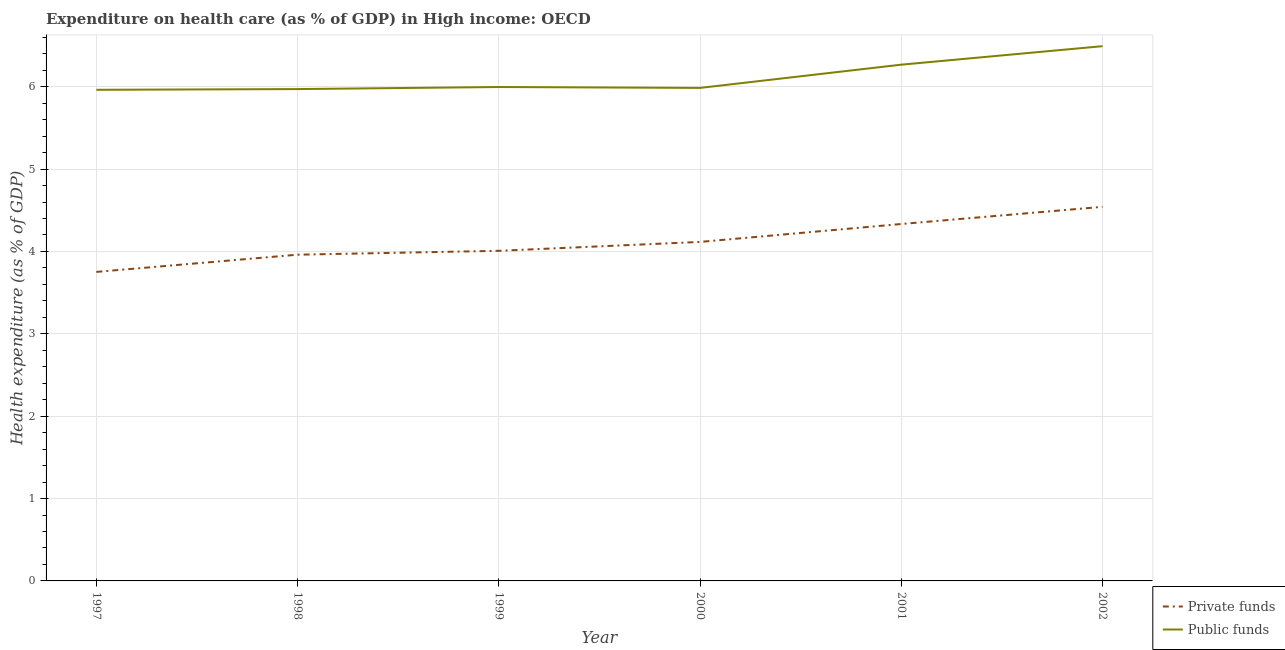What is the amount of public funds spent in healthcare in 1998?
Your response must be concise. 5.97. Across all years, what is the maximum amount of public funds spent in healthcare?
Provide a short and direct response. 6.49. Across all years, what is the minimum amount of public funds spent in healthcare?
Your answer should be very brief. 5.96. In which year was the amount of public funds spent in healthcare minimum?
Keep it short and to the point. 1997. What is the total amount of private funds spent in healthcare in the graph?
Offer a terse response. 24.71. What is the difference between the amount of public funds spent in healthcare in 1997 and that in 2000?
Your answer should be compact. -0.02. What is the difference between the amount of private funds spent in healthcare in 1999 and the amount of public funds spent in healthcare in 2001?
Make the answer very short. -2.26. What is the average amount of public funds spent in healthcare per year?
Ensure brevity in your answer.  6.11. In the year 2001, what is the difference between the amount of private funds spent in healthcare and amount of public funds spent in healthcare?
Give a very brief answer. -1.93. What is the ratio of the amount of private funds spent in healthcare in 1997 to that in 2002?
Make the answer very short. 0.83. Is the difference between the amount of public funds spent in healthcare in 1997 and 1999 greater than the difference between the amount of private funds spent in healthcare in 1997 and 1999?
Give a very brief answer. Yes. What is the difference between the highest and the second highest amount of private funds spent in healthcare?
Make the answer very short. 0.21. What is the difference between the highest and the lowest amount of private funds spent in healthcare?
Offer a very short reply. 0.79. In how many years, is the amount of private funds spent in healthcare greater than the average amount of private funds spent in healthcare taken over all years?
Your answer should be compact. 2. Is the sum of the amount of private funds spent in healthcare in 1999 and 2000 greater than the maximum amount of public funds spent in healthcare across all years?
Provide a succinct answer. Yes. Is the amount of private funds spent in healthcare strictly less than the amount of public funds spent in healthcare over the years?
Make the answer very short. Yes. Are the values on the major ticks of Y-axis written in scientific E-notation?
Offer a very short reply. No. Does the graph contain any zero values?
Provide a short and direct response. No. How are the legend labels stacked?
Ensure brevity in your answer.  Vertical. What is the title of the graph?
Your response must be concise. Expenditure on health care (as % of GDP) in High income: OECD. What is the label or title of the X-axis?
Your response must be concise. Year. What is the label or title of the Y-axis?
Offer a very short reply. Health expenditure (as % of GDP). What is the Health expenditure (as % of GDP) of Private funds in 1997?
Provide a short and direct response. 3.75. What is the Health expenditure (as % of GDP) in Public funds in 1997?
Offer a very short reply. 5.96. What is the Health expenditure (as % of GDP) of Private funds in 1998?
Provide a succinct answer. 3.96. What is the Health expenditure (as % of GDP) in Public funds in 1998?
Provide a succinct answer. 5.97. What is the Health expenditure (as % of GDP) in Private funds in 1999?
Make the answer very short. 4.01. What is the Health expenditure (as % of GDP) in Public funds in 1999?
Make the answer very short. 6. What is the Health expenditure (as % of GDP) of Private funds in 2000?
Make the answer very short. 4.12. What is the Health expenditure (as % of GDP) in Public funds in 2000?
Offer a terse response. 5.99. What is the Health expenditure (as % of GDP) in Private funds in 2001?
Your answer should be very brief. 4.33. What is the Health expenditure (as % of GDP) in Public funds in 2001?
Ensure brevity in your answer.  6.27. What is the Health expenditure (as % of GDP) in Private funds in 2002?
Your answer should be very brief. 4.54. What is the Health expenditure (as % of GDP) of Public funds in 2002?
Provide a short and direct response. 6.49. Across all years, what is the maximum Health expenditure (as % of GDP) in Private funds?
Your answer should be compact. 4.54. Across all years, what is the maximum Health expenditure (as % of GDP) in Public funds?
Ensure brevity in your answer.  6.49. Across all years, what is the minimum Health expenditure (as % of GDP) of Private funds?
Offer a very short reply. 3.75. Across all years, what is the minimum Health expenditure (as % of GDP) in Public funds?
Make the answer very short. 5.96. What is the total Health expenditure (as % of GDP) in Private funds in the graph?
Give a very brief answer. 24.71. What is the total Health expenditure (as % of GDP) of Public funds in the graph?
Offer a very short reply. 36.68. What is the difference between the Health expenditure (as % of GDP) in Private funds in 1997 and that in 1998?
Offer a terse response. -0.21. What is the difference between the Health expenditure (as % of GDP) in Public funds in 1997 and that in 1998?
Make the answer very short. -0.01. What is the difference between the Health expenditure (as % of GDP) of Private funds in 1997 and that in 1999?
Your answer should be very brief. -0.26. What is the difference between the Health expenditure (as % of GDP) of Public funds in 1997 and that in 1999?
Provide a short and direct response. -0.03. What is the difference between the Health expenditure (as % of GDP) of Private funds in 1997 and that in 2000?
Your answer should be very brief. -0.36. What is the difference between the Health expenditure (as % of GDP) of Public funds in 1997 and that in 2000?
Your response must be concise. -0.02. What is the difference between the Health expenditure (as % of GDP) of Private funds in 1997 and that in 2001?
Keep it short and to the point. -0.58. What is the difference between the Health expenditure (as % of GDP) of Public funds in 1997 and that in 2001?
Provide a succinct answer. -0.3. What is the difference between the Health expenditure (as % of GDP) in Private funds in 1997 and that in 2002?
Offer a very short reply. -0.79. What is the difference between the Health expenditure (as % of GDP) of Public funds in 1997 and that in 2002?
Your response must be concise. -0.53. What is the difference between the Health expenditure (as % of GDP) in Private funds in 1998 and that in 1999?
Offer a very short reply. -0.05. What is the difference between the Health expenditure (as % of GDP) of Public funds in 1998 and that in 1999?
Ensure brevity in your answer.  -0.02. What is the difference between the Health expenditure (as % of GDP) in Private funds in 1998 and that in 2000?
Offer a very short reply. -0.15. What is the difference between the Health expenditure (as % of GDP) in Public funds in 1998 and that in 2000?
Your answer should be compact. -0.01. What is the difference between the Health expenditure (as % of GDP) in Private funds in 1998 and that in 2001?
Your answer should be compact. -0.37. What is the difference between the Health expenditure (as % of GDP) in Public funds in 1998 and that in 2001?
Your response must be concise. -0.3. What is the difference between the Health expenditure (as % of GDP) of Private funds in 1998 and that in 2002?
Provide a short and direct response. -0.58. What is the difference between the Health expenditure (as % of GDP) in Public funds in 1998 and that in 2002?
Make the answer very short. -0.52. What is the difference between the Health expenditure (as % of GDP) in Private funds in 1999 and that in 2000?
Provide a succinct answer. -0.11. What is the difference between the Health expenditure (as % of GDP) in Public funds in 1999 and that in 2000?
Offer a terse response. 0.01. What is the difference between the Health expenditure (as % of GDP) of Private funds in 1999 and that in 2001?
Provide a short and direct response. -0.33. What is the difference between the Health expenditure (as % of GDP) in Public funds in 1999 and that in 2001?
Make the answer very short. -0.27. What is the difference between the Health expenditure (as % of GDP) of Private funds in 1999 and that in 2002?
Provide a succinct answer. -0.53. What is the difference between the Health expenditure (as % of GDP) in Public funds in 1999 and that in 2002?
Keep it short and to the point. -0.5. What is the difference between the Health expenditure (as % of GDP) in Private funds in 2000 and that in 2001?
Your answer should be compact. -0.22. What is the difference between the Health expenditure (as % of GDP) of Public funds in 2000 and that in 2001?
Your answer should be very brief. -0.28. What is the difference between the Health expenditure (as % of GDP) of Private funds in 2000 and that in 2002?
Ensure brevity in your answer.  -0.43. What is the difference between the Health expenditure (as % of GDP) of Public funds in 2000 and that in 2002?
Provide a succinct answer. -0.51. What is the difference between the Health expenditure (as % of GDP) in Private funds in 2001 and that in 2002?
Your answer should be very brief. -0.21. What is the difference between the Health expenditure (as % of GDP) of Public funds in 2001 and that in 2002?
Offer a terse response. -0.22. What is the difference between the Health expenditure (as % of GDP) of Private funds in 1997 and the Health expenditure (as % of GDP) of Public funds in 1998?
Offer a very short reply. -2.22. What is the difference between the Health expenditure (as % of GDP) in Private funds in 1997 and the Health expenditure (as % of GDP) in Public funds in 1999?
Give a very brief answer. -2.24. What is the difference between the Health expenditure (as % of GDP) in Private funds in 1997 and the Health expenditure (as % of GDP) in Public funds in 2000?
Provide a short and direct response. -2.23. What is the difference between the Health expenditure (as % of GDP) of Private funds in 1997 and the Health expenditure (as % of GDP) of Public funds in 2001?
Provide a succinct answer. -2.52. What is the difference between the Health expenditure (as % of GDP) of Private funds in 1997 and the Health expenditure (as % of GDP) of Public funds in 2002?
Your response must be concise. -2.74. What is the difference between the Health expenditure (as % of GDP) in Private funds in 1998 and the Health expenditure (as % of GDP) in Public funds in 1999?
Make the answer very short. -2.04. What is the difference between the Health expenditure (as % of GDP) of Private funds in 1998 and the Health expenditure (as % of GDP) of Public funds in 2000?
Offer a terse response. -2.02. What is the difference between the Health expenditure (as % of GDP) of Private funds in 1998 and the Health expenditure (as % of GDP) of Public funds in 2001?
Ensure brevity in your answer.  -2.31. What is the difference between the Health expenditure (as % of GDP) in Private funds in 1998 and the Health expenditure (as % of GDP) in Public funds in 2002?
Give a very brief answer. -2.53. What is the difference between the Health expenditure (as % of GDP) in Private funds in 1999 and the Health expenditure (as % of GDP) in Public funds in 2000?
Ensure brevity in your answer.  -1.98. What is the difference between the Health expenditure (as % of GDP) of Private funds in 1999 and the Health expenditure (as % of GDP) of Public funds in 2001?
Your answer should be very brief. -2.26. What is the difference between the Health expenditure (as % of GDP) in Private funds in 1999 and the Health expenditure (as % of GDP) in Public funds in 2002?
Offer a very short reply. -2.48. What is the difference between the Health expenditure (as % of GDP) in Private funds in 2000 and the Health expenditure (as % of GDP) in Public funds in 2001?
Offer a very short reply. -2.15. What is the difference between the Health expenditure (as % of GDP) of Private funds in 2000 and the Health expenditure (as % of GDP) of Public funds in 2002?
Offer a terse response. -2.38. What is the difference between the Health expenditure (as % of GDP) in Private funds in 2001 and the Health expenditure (as % of GDP) in Public funds in 2002?
Provide a short and direct response. -2.16. What is the average Health expenditure (as % of GDP) of Private funds per year?
Your answer should be very brief. 4.12. What is the average Health expenditure (as % of GDP) in Public funds per year?
Give a very brief answer. 6.11. In the year 1997, what is the difference between the Health expenditure (as % of GDP) in Private funds and Health expenditure (as % of GDP) in Public funds?
Your answer should be very brief. -2.21. In the year 1998, what is the difference between the Health expenditure (as % of GDP) of Private funds and Health expenditure (as % of GDP) of Public funds?
Your answer should be very brief. -2.01. In the year 1999, what is the difference between the Health expenditure (as % of GDP) in Private funds and Health expenditure (as % of GDP) in Public funds?
Your response must be concise. -1.99. In the year 2000, what is the difference between the Health expenditure (as % of GDP) in Private funds and Health expenditure (as % of GDP) in Public funds?
Offer a very short reply. -1.87. In the year 2001, what is the difference between the Health expenditure (as % of GDP) in Private funds and Health expenditure (as % of GDP) in Public funds?
Your answer should be very brief. -1.93. In the year 2002, what is the difference between the Health expenditure (as % of GDP) of Private funds and Health expenditure (as % of GDP) of Public funds?
Provide a succinct answer. -1.95. What is the ratio of the Health expenditure (as % of GDP) in Private funds in 1997 to that in 1998?
Offer a terse response. 0.95. What is the ratio of the Health expenditure (as % of GDP) in Public funds in 1997 to that in 1998?
Provide a succinct answer. 1. What is the ratio of the Health expenditure (as % of GDP) of Private funds in 1997 to that in 1999?
Offer a terse response. 0.94. What is the ratio of the Health expenditure (as % of GDP) of Public funds in 1997 to that in 1999?
Offer a terse response. 0.99. What is the ratio of the Health expenditure (as % of GDP) of Private funds in 1997 to that in 2000?
Keep it short and to the point. 0.91. What is the ratio of the Health expenditure (as % of GDP) in Public funds in 1997 to that in 2000?
Offer a very short reply. 1. What is the ratio of the Health expenditure (as % of GDP) of Private funds in 1997 to that in 2001?
Offer a terse response. 0.87. What is the ratio of the Health expenditure (as % of GDP) in Public funds in 1997 to that in 2001?
Your answer should be compact. 0.95. What is the ratio of the Health expenditure (as % of GDP) of Private funds in 1997 to that in 2002?
Your answer should be compact. 0.83. What is the ratio of the Health expenditure (as % of GDP) of Public funds in 1997 to that in 2002?
Provide a short and direct response. 0.92. What is the ratio of the Health expenditure (as % of GDP) of Private funds in 1998 to that in 1999?
Provide a short and direct response. 0.99. What is the ratio of the Health expenditure (as % of GDP) of Private funds in 1998 to that in 2000?
Offer a very short reply. 0.96. What is the ratio of the Health expenditure (as % of GDP) of Private funds in 1998 to that in 2001?
Offer a very short reply. 0.91. What is the ratio of the Health expenditure (as % of GDP) of Public funds in 1998 to that in 2001?
Provide a succinct answer. 0.95. What is the ratio of the Health expenditure (as % of GDP) of Private funds in 1998 to that in 2002?
Offer a very short reply. 0.87. What is the ratio of the Health expenditure (as % of GDP) in Public funds in 1998 to that in 2002?
Give a very brief answer. 0.92. What is the ratio of the Health expenditure (as % of GDP) in Private funds in 1999 to that in 2000?
Provide a succinct answer. 0.97. What is the ratio of the Health expenditure (as % of GDP) in Private funds in 1999 to that in 2001?
Make the answer very short. 0.92. What is the ratio of the Health expenditure (as % of GDP) in Public funds in 1999 to that in 2001?
Make the answer very short. 0.96. What is the ratio of the Health expenditure (as % of GDP) of Private funds in 1999 to that in 2002?
Keep it short and to the point. 0.88. What is the ratio of the Health expenditure (as % of GDP) in Public funds in 1999 to that in 2002?
Your answer should be very brief. 0.92. What is the ratio of the Health expenditure (as % of GDP) of Private funds in 2000 to that in 2001?
Provide a short and direct response. 0.95. What is the ratio of the Health expenditure (as % of GDP) in Public funds in 2000 to that in 2001?
Offer a very short reply. 0.95. What is the ratio of the Health expenditure (as % of GDP) of Private funds in 2000 to that in 2002?
Offer a very short reply. 0.91. What is the ratio of the Health expenditure (as % of GDP) in Public funds in 2000 to that in 2002?
Your answer should be very brief. 0.92. What is the ratio of the Health expenditure (as % of GDP) in Private funds in 2001 to that in 2002?
Ensure brevity in your answer.  0.95. What is the ratio of the Health expenditure (as % of GDP) in Public funds in 2001 to that in 2002?
Give a very brief answer. 0.97. What is the difference between the highest and the second highest Health expenditure (as % of GDP) in Private funds?
Your answer should be compact. 0.21. What is the difference between the highest and the second highest Health expenditure (as % of GDP) of Public funds?
Offer a terse response. 0.22. What is the difference between the highest and the lowest Health expenditure (as % of GDP) in Private funds?
Offer a terse response. 0.79. What is the difference between the highest and the lowest Health expenditure (as % of GDP) of Public funds?
Ensure brevity in your answer.  0.53. 